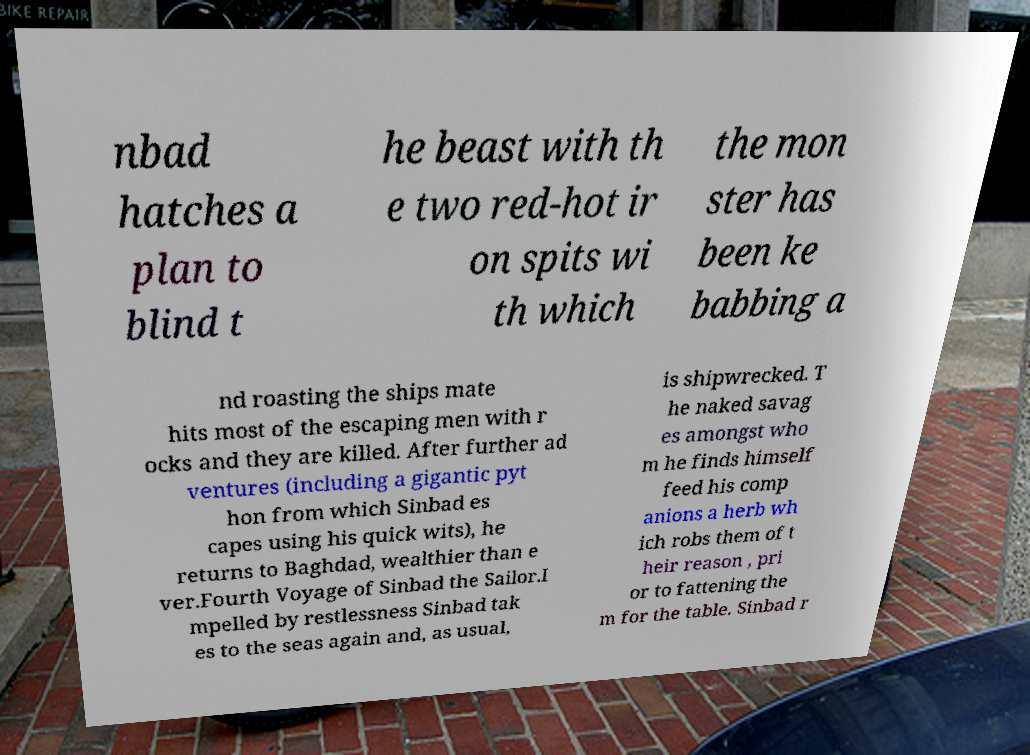Please read and relay the text visible in this image. What does it say? nbad hatches a plan to blind t he beast with th e two red-hot ir on spits wi th which the mon ster has been ke babbing a nd roasting the ships mate hits most of the escaping men with r ocks and they are killed. After further ad ventures (including a gigantic pyt hon from which Sinbad es capes using his quick wits), he returns to Baghdad, wealthier than e ver.Fourth Voyage of Sinbad the Sailor.I mpelled by restlessness Sinbad tak es to the seas again and, as usual, is shipwrecked. T he naked savag es amongst who m he finds himself feed his comp anions a herb wh ich robs them of t heir reason , pri or to fattening the m for the table. Sinbad r 